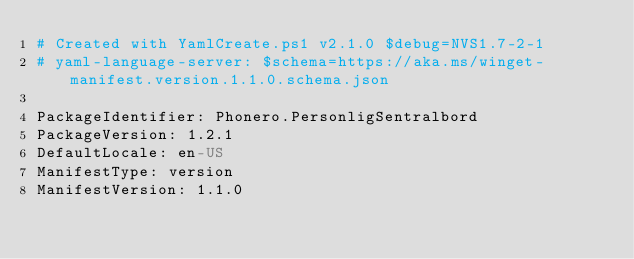Convert code to text. <code><loc_0><loc_0><loc_500><loc_500><_YAML_># Created with YamlCreate.ps1 v2.1.0 $debug=NVS1.7-2-1
# yaml-language-server: $schema=https://aka.ms/winget-manifest.version.1.1.0.schema.json

PackageIdentifier: Phonero.PersonligSentralbord
PackageVersion: 1.2.1
DefaultLocale: en-US
ManifestType: version
ManifestVersion: 1.1.0
</code> 